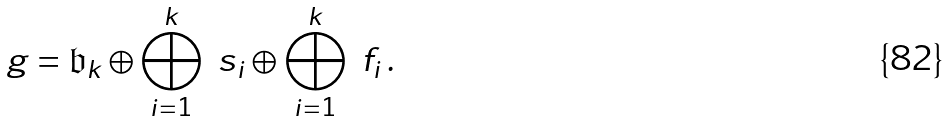Convert formula to latex. <formula><loc_0><loc_0><loc_500><loc_500>\ g = \mathfrak { b } _ { k } \oplus \bigoplus _ { i = 1 } ^ { k } \ s _ { i } \oplus \bigoplus _ { i = 1 } ^ { k } \ f _ { i } \, .</formula> 